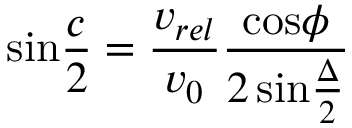Convert formula to latex. <formula><loc_0><loc_0><loc_500><loc_500>\sin { \frac { c } { 2 } } = { \frac { v _ { r e l } } { v _ { 0 } } } { \frac { \cos \phi } { 2 \, \sin { \frac { \Delta } { 2 } } } }</formula> 